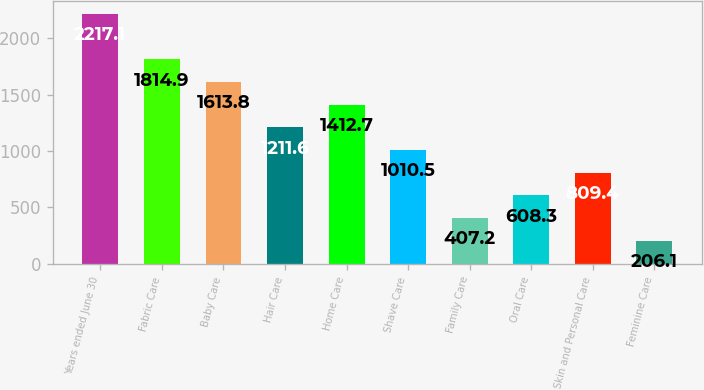Convert chart to OTSL. <chart><loc_0><loc_0><loc_500><loc_500><bar_chart><fcel>Years ended June 30<fcel>Fabric Care<fcel>Baby Care<fcel>Hair Care<fcel>Home Care<fcel>Shave Care<fcel>Family Care<fcel>Oral Care<fcel>Skin and Personal Care<fcel>Feminine Care<nl><fcel>2217.1<fcel>1814.9<fcel>1613.8<fcel>1211.6<fcel>1412.7<fcel>1010.5<fcel>407.2<fcel>608.3<fcel>809.4<fcel>206.1<nl></chart> 